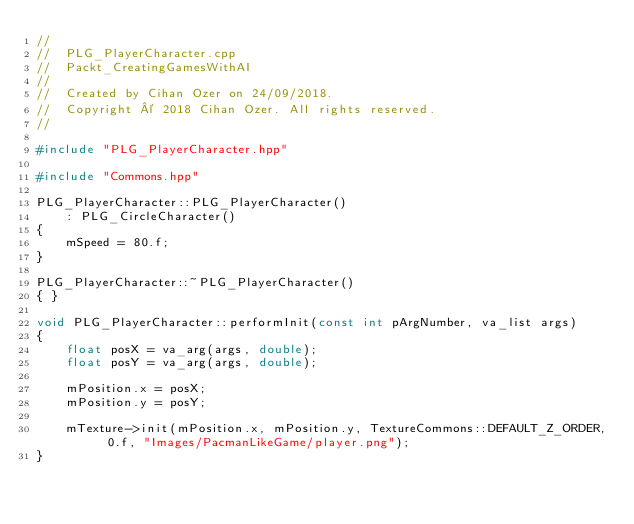<code> <loc_0><loc_0><loc_500><loc_500><_C++_>//
//  PLG_PlayerCharacter.cpp
//  Packt_CreatingGamesWithAI
//
//  Created by Cihan Ozer on 24/09/2018.
//  Copyright © 2018 Cihan Ozer. All rights reserved.
//

#include "PLG_PlayerCharacter.hpp"

#include "Commons.hpp"

PLG_PlayerCharacter::PLG_PlayerCharacter()
    : PLG_CircleCharacter()
{
    mSpeed = 80.f;
}

PLG_PlayerCharacter::~PLG_PlayerCharacter()
{ }

void PLG_PlayerCharacter::performInit(const int pArgNumber, va_list args)
{
    float posX = va_arg(args, double);
    float posY = va_arg(args, double);
    
    mPosition.x = posX;
    mPosition.y = posY;
    
    mTexture->init(mPosition.x, mPosition.y, TextureCommons::DEFAULT_Z_ORDER, 0.f, "Images/PacmanLikeGame/player.png");
}
</code> 